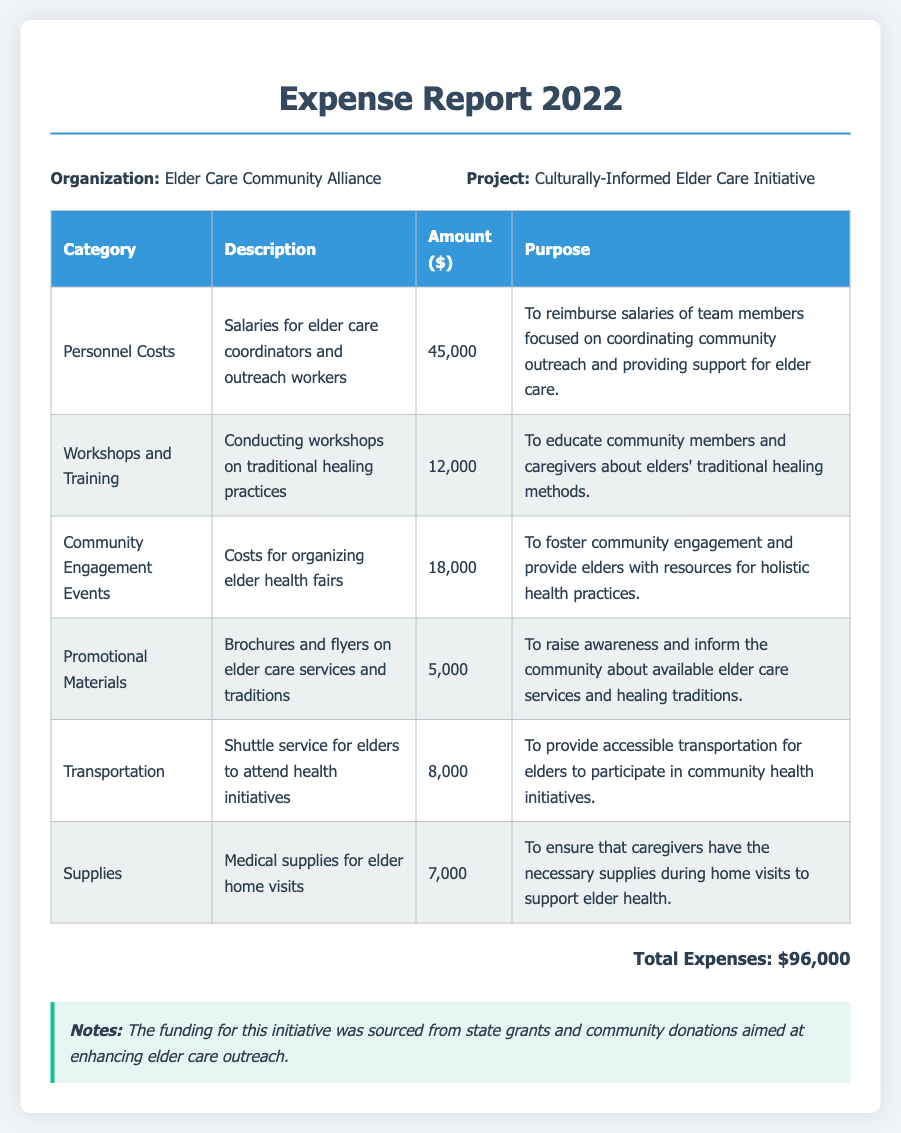what is the total amount of expenses? The total expenses are listed at the end of the document as the sum of all categories.
Answer: $96,000 what is the category with the highest expense? By comparing the amounts in each category, the one with the highest expense can be identified.
Answer: Personnel Costs how much was spent on workshops and training? The specific amount allocated for workshops and training is provided in the expense breakdown.
Answer: $12,000 what purpose does the transportation expense serve? The document provides a description of the purpose for which transportation funds were allocated.
Answer: To provide accessible transportation for elders to participate in community health initiatives how many different categories of expenses are listed? The number of unique expense categories can be counted from the table in the document.
Answer: 6 what is the description for promotional materials? The document contains a description related to promotional materials under the relevant category.
Answer: Brochures and flyers on elder care services and traditions what was the main source of funding for this initiative? The notes section specifies the source of funding for the program.
Answer: State grants and community donations what is the project title for this expense report? The project title is explicitly stated in the information section of the document.
Answer: Culturally-Informed Elder Care Initiative 